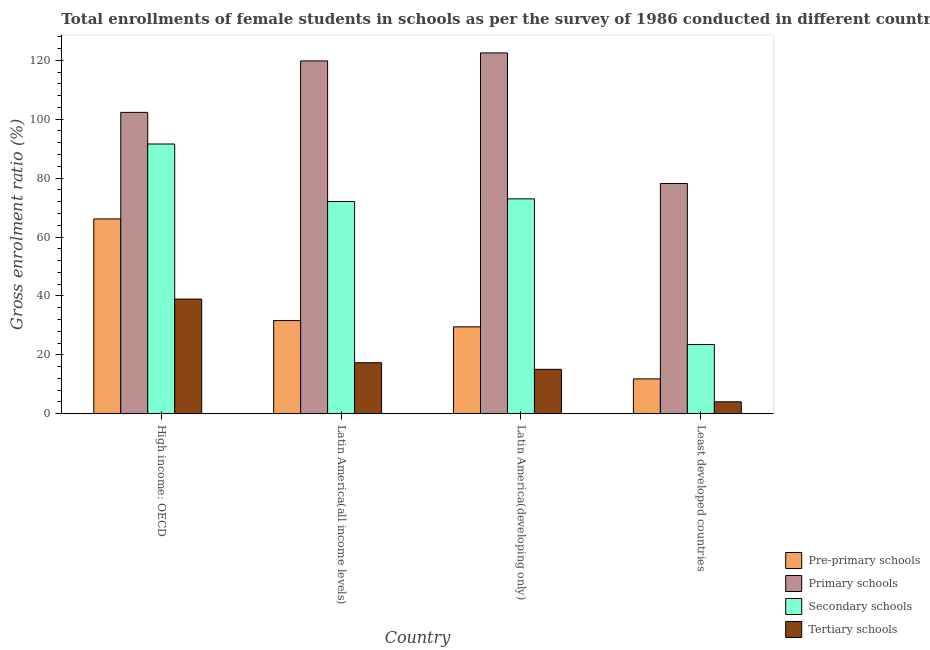How many groups of bars are there?
Give a very brief answer. 4. Are the number of bars per tick equal to the number of legend labels?
Make the answer very short. Yes. How many bars are there on the 1st tick from the right?
Give a very brief answer. 4. What is the label of the 1st group of bars from the left?
Your answer should be very brief. High income: OECD. What is the gross enrolment ratio(female) in primary schools in Latin America(all income levels)?
Your answer should be very brief. 119.79. Across all countries, what is the maximum gross enrolment ratio(female) in secondary schools?
Keep it short and to the point. 91.58. Across all countries, what is the minimum gross enrolment ratio(female) in tertiary schools?
Make the answer very short. 4.05. In which country was the gross enrolment ratio(female) in primary schools maximum?
Make the answer very short. Latin America(developing only). In which country was the gross enrolment ratio(female) in secondary schools minimum?
Provide a succinct answer. Least developed countries. What is the total gross enrolment ratio(female) in pre-primary schools in the graph?
Your answer should be compact. 139.11. What is the difference between the gross enrolment ratio(female) in primary schools in Latin America(developing only) and that in Least developed countries?
Make the answer very short. 44.34. What is the difference between the gross enrolment ratio(female) in pre-primary schools in Latin America(developing only) and the gross enrolment ratio(female) in secondary schools in Least developed countries?
Provide a short and direct response. 6. What is the average gross enrolment ratio(female) in tertiary schools per country?
Ensure brevity in your answer.  18.84. What is the difference between the gross enrolment ratio(female) in primary schools and gross enrolment ratio(female) in tertiary schools in Least developed countries?
Offer a terse response. 74.11. In how many countries, is the gross enrolment ratio(female) in primary schools greater than 76 %?
Make the answer very short. 4. What is the ratio of the gross enrolment ratio(female) in secondary schools in Latin America(all income levels) to that in Latin America(developing only)?
Your response must be concise. 0.99. What is the difference between the highest and the second highest gross enrolment ratio(female) in secondary schools?
Offer a very short reply. 18.62. What is the difference between the highest and the lowest gross enrolment ratio(female) in primary schools?
Keep it short and to the point. 44.34. Is the sum of the gross enrolment ratio(female) in pre-primary schools in Latin America(developing only) and Least developed countries greater than the maximum gross enrolment ratio(female) in secondary schools across all countries?
Ensure brevity in your answer.  No. What does the 1st bar from the left in High income: OECD represents?
Provide a succinct answer. Pre-primary schools. What does the 1st bar from the right in Least developed countries represents?
Offer a very short reply. Tertiary schools. Is it the case that in every country, the sum of the gross enrolment ratio(female) in pre-primary schools and gross enrolment ratio(female) in primary schools is greater than the gross enrolment ratio(female) in secondary schools?
Provide a short and direct response. Yes. Does the graph contain any zero values?
Make the answer very short. No. Where does the legend appear in the graph?
Provide a short and direct response. Bottom right. How are the legend labels stacked?
Your answer should be compact. Vertical. What is the title of the graph?
Provide a short and direct response. Total enrollments of female students in schools as per the survey of 1986 conducted in different countries. What is the Gross enrolment ratio (%) in Pre-primary schools in High income: OECD?
Keep it short and to the point. 66.15. What is the Gross enrolment ratio (%) of Primary schools in High income: OECD?
Offer a terse response. 102.32. What is the Gross enrolment ratio (%) in Secondary schools in High income: OECD?
Provide a succinct answer. 91.58. What is the Gross enrolment ratio (%) in Tertiary schools in High income: OECD?
Provide a short and direct response. 38.93. What is the Gross enrolment ratio (%) of Pre-primary schools in Latin America(all income levels)?
Ensure brevity in your answer.  31.63. What is the Gross enrolment ratio (%) of Primary schools in Latin America(all income levels)?
Ensure brevity in your answer.  119.79. What is the Gross enrolment ratio (%) of Secondary schools in Latin America(all income levels)?
Your answer should be compact. 72.05. What is the Gross enrolment ratio (%) in Tertiary schools in Latin America(all income levels)?
Make the answer very short. 17.33. What is the Gross enrolment ratio (%) in Pre-primary schools in Latin America(developing only)?
Make the answer very short. 29.5. What is the Gross enrolment ratio (%) in Primary schools in Latin America(developing only)?
Provide a short and direct response. 122.51. What is the Gross enrolment ratio (%) in Secondary schools in Latin America(developing only)?
Provide a succinct answer. 72.96. What is the Gross enrolment ratio (%) of Tertiary schools in Latin America(developing only)?
Your answer should be very brief. 15.08. What is the Gross enrolment ratio (%) of Pre-primary schools in Least developed countries?
Provide a succinct answer. 11.84. What is the Gross enrolment ratio (%) in Primary schools in Least developed countries?
Your response must be concise. 78.16. What is the Gross enrolment ratio (%) in Secondary schools in Least developed countries?
Offer a very short reply. 23.5. What is the Gross enrolment ratio (%) of Tertiary schools in Least developed countries?
Make the answer very short. 4.05. Across all countries, what is the maximum Gross enrolment ratio (%) of Pre-primary schools?
Keep it short and to the point. 66.15. Across all countries, what is the maximum Gross enrolment ratio (%) in Primary schools?
Keep it short and to the point. 122.51. Across all countries, what is the maximum Gross enrolment ratio (%) in Secondary schools?
Keep it short and to the point. 91.58. Across all countries, what is the maximum Gross enrolment ratio (%) in Tertiary schools?
Ensure brevity in your answer.  38.93. Across all countries, what is the minimum Gross enrolment ratio (%) in Pre-primary schools?
Give a very brief answer. 11.84. Across all countries, what is the minimum Gross enrolment ratio (%) in Primary schools?
Offer a very short reply. 78.16. Across all countries, what is the minimum Gross enrolment ratio (%) in Secondary schools?
Keep it short and to the point. 23.5. Across all countries, what is the minimum Gross enrolment ratio (%) of Tertiary schools?
Provide a succinct answer. 4.05. What is the total Gross enrolment ratio (%) in Pre-primary schools in the graph?
Give a very brief answer. 139.11. What is the total Gross enrolment ratio (%) in Primary schools in the graph?
Provide a short and direct response. 422.78. What is the total Gross enrolment ratio (%) in Secondary schools in the graph?
Offer a terse response. 260.09. What is the total Gross enrolment ratio (%) of Tertiary schools in the graph?
Keep it short and to the point. 75.38. What is the difference between the Gross enrolment ratio (%) in Pre-primary schools in High income: OECD and that in Latin America(all income levels)?
Your answer should be very brief. 34.52. What is the difference between the Gross enrolment ratio (%) of Primary schools in High income: OECD and that in Latin America(all income levels)?
Ensure brevity in your answer.  -17.47. What is the difference between the Gross enrolment ratio (%) of Secondary schools in High income: OECD and that in Latin America(all income levels)?
Your answer should be very brief. 19.53. What is the difference between the Gross enrolment ratio (%) in Tertiary schools in High income: OECD and that in Latin America(all income levels)?
Ensure brevity in your answer.  21.6. What is the difference between the Gross enrolment ratio (%) in Pre-primary schools in High income: OECD and that in Latin America(developing only)?
Give a very brief answer. 36.64. What is the difference between the Gross enrolment ratio (%) of Primary schools in High income: OECD and that in Latin America(developing only)?
Your response must be concise. -20.19. What is the difference between the Gross enrolment ratio (%) in Secondary schools in High income: OECD and that in Latin America(developing only)?
Provide a short and direct response. 18.62. What is the difference between the Gross enrolment ratio (%) in Tertiary schools in High income: OECD and that in Latin America(developing only)?
Provide a succinct answer. 23.85. What is the difference between the Gross enrolment ratio (%) in Pre-primary schools in High income: OECD and that in Least developed countries?
Keep it short and to the point. 54.31. What is the difference between the Gross enrolment ratio (%) in Primary schools in High income: OECD and that in Least developed countries?
Ensure brevity in your answer.  24.16. What is the difference between the Gross enrolment ratio (%) in Secondary schools in High income: OECD and that in Least developed countries?
Make the answer very short. 68.08. What is the difference between the Gross enrolment ratio (%) in Tertiary schools in High income: OECD and that in Least developed countries?
Your answer should be compact. 34.88. What is the difference between the Gross enrolment ratio (%) of Pre-primary schools in Latin America(all income levels) and that in Latin America(developing only)?
Your answer should be compact. 2.13. What is the difference between the Gross enrolment ratio (%) of Primary schools in Latin America(all income levels) and that in Latin America(developing only)?
Offer a terse response. -2.71. What is the difference between the Gross enrolment ratio (%) of Secondary schools in Latin America(all income levels) and that in Latin America(developing only)?
Provide a short and direct response. -0.9. What is the difference between the Gross enrolment ratio (%) of Tertiary schools in Latin America(all income levels) and that in Latin America(developing only)?
Provide a short and direct response. 2.25. What is the difference between the Gross enrolment ratio (%) in Pre-primary schools in Latin America(all income levels) and that in Least developed countries?
Offer a terse response. 19.79. What is the difference between the Gross enrolment ratio (%) of Primary schools in Latin America(all income levels) and that in Least developed countries?
Your response must be concise. 41.63. What is the difference between the Gross enrolment ratio (%) in Secondary schools in Latin America(all income levels) and that in Least developed countries?
Your answer should be very brief. 48.55. What is the difference between the Gross enrolment ratio (%) in Tertiary schools in Latin America(all income levels) and that in Least developed countries?
Keep it short and to the point. 13.28. What is the difference between the Gross enrolment ratio (%) in Pre-primary schools in Latin America(developing only) and that in Least developed countries?
Ensure brevity in your answer.  17.67. What is the difference between the Gross enrolment ratio (%) of Primary schools in Latin America(developing only) and that in Least developed countries?
Provide a short and direct response. 44.34. What is the difference between the Gross enrolment ratio (%) in Secondary schools in Latin America(developing only) and that in Least developed countries?
Give a very brief answer. 49.46. What is the difference between the Gross enrolment ratio (%) of Tertiary schools in Latin America(developing only) and that in Least developed countries?
Give a very brief answer. 11.03. What is the difference between the Gross enrolment ratio (%) of Pre-primary schools in High income: OECD and the Gross enrolment ratio (%) of Primary schools in Latin America(all income levels)?
Ensure brevity in your answer.  -53.65. What is the difference between the Gross enrolment ratio (%) of Pre-primary schools in High income: OECD and the Gross enrolment ratio (%) of Secondary schools in Latin America(all income levels)?
Your answer should be very brief. -5.91. What is the difference between the Gross enrolment ratio (%) in Pre-primary schools in High income: OECD and the Gross enrolment ratio (%) in Tertiary schools in Latin America(all income levels)?
Provide a succinct answer. 48.82. What is the difference between the Gross enrolment ratio (%) in Primary schools in High income: OECD and the Gross enrolment ratio (%) in Secondary schools in Latin America(all income levels)?
Offer a terse response. 30.27. What is the difference between the Gross enrolment ratio (%) in Primary schools in High income: OECD and the Gross enrolment ratio (%) in Tertiary schools in Latin America(all income levels)?
Offer a very short reply. 84.99. What is the difference between the Gross enrolment ratio (%) of Secondary schools in High income: OECD and the Gross enrolment ratio (%) of Tertiary schools in Latin America(all income levels)?
Offer a terse response. 74.25. What is the difference between the Gross enrolment ratio (%) of Pre-primary schools in High income: OECD and the Gross enrolment ratio (%) of Primary schools in Latin America(developing only)?
Keep it short and to the point. -56.36. What is the difference between the Gross enrolment ratio (%) of Pre-primary schools in High income: OECD and the Gross enrolment ratio (%) of Secondary schools in Latin America(developing only)?
Offer a terse response. -6.81. What is the difference between the Gross enrolment ratio (%) of Pre-primary schools in High income: OECD and the Gross enrolment ratio (%) of Tertiary schools in Latin America(developing only)?
Keep it short and to the point. 51.07. What is the difference between the Gross enrolment ratio (%) of Primary schools in High income: OECD and the Gross enrolment ratio (%) of Secondary schools in Latin America(developing only)?
Your answer should be compact. 29.36. What is the difference between the Gross enrolment ratio (%) of Primary schools in High income: OECD and the Gross enrolment ratio (%) of Tertiary schools in Latin America(developing only)?
Make the answer very short. 87.24. What is the difference between the Gross enrolment ratio (%) in Secondary schools in High income: OECD and the Gross enrolment ratio (%) in Tertiary schools in Latin America(developing only)?
Keep it short and to the point. 76.5. What is the difference between the Gross enrolment ratio (%) of Pre-primary schools in High income: OECD and the Gross enrolment ratio (%) of Primary schools in Least developed countries?
Your answer should be very brief. -12.02. What is the difference between the Gross enrolment ratio (%) in Pre-primary schools in High income: OECD and the Gross enrolment ratio (%) in Secondary schools in Least developed countries?
Ensure brevity in your answer.  42.65. What is the difference between the Gross enrolment ratio (%) of Pre-primary schools in High income: OECD and the Gross enrolment ratio (%) of Tertiary schools in Least developed countries?
Your answer should be compact. 62.1. What is the difference between the Gross enrolment ratio (%) of Primary schools in High income: OECD and the Gross enrolment ratio (%) of Secondary schools in Least developed countries?
Your answer should be compact. 78.82. What is the difference between the Gross enrolment ratio (%) of Primary schools in High income: OECD and the Gross enrolment ratio (%) of Tertiary schools in Least developed countries?
Offer a terse response. 98.27. What is the difference between the Gross enrolment ratio (%) in Secondary schools in High income: OECD and the Gross enrolment ratio (%) in Tertiary schools in Least developed countries?
Your response must be concise. 87.53. What is the difference between the Gross enrolment ratio (%) in Pre-primary schools in Latin America(all income levels) and the Gross enrolment ratio (%) in Primary schools in Latin America(developing only)?
Offer a terse response. -90.88. What is the difference between the Gross enrolment ratio (%) in Pre-primary schools in Latin America(all income levels) and the Gross enrolment ratio (%) in Secondary schools in Latin America(developing only)?
Give a very brief answer. -41.33. What is the difference between the Gross enrolment ratio (%) in Pre-primary schools in Latin America(all income levels) and the Gross enrolment ratio (%) in Tertiary schools in Latin America(developing only)?
Ensure brevity in your answer.  16.55. What is the difference between the Gross enrolment ratio (%) in Primary schools in Latin America(all income levels) and the Gross enrolment ratio (%) in Secondary schools in Latin America(developing only)?
Offer a terse response. 46.84. What is the difference between the Gross enrolment ratio (%) of Primary schools in Latin America(all income levels) and the Gross enrolment ratio (%) of Tertiary schools in Latin America(developing only)?
Your response must be concise. 104.72. What is the difference between the Gross enrolment ratio (%) in Secondary schools in Latin America(all income levels) and the Gross enrolment ratio (%) in Tertiary schools in Latin America(developing only)?
Keep it short and to the point. 56.98. What is the difference between the Gross enrolment ratio (%) of Pre-primary schools in Latin America(all income levels) and the Gross enrolment ratio (%) of Primary schools in Least developed countries?
Give a very brief answer. -46.53. What is the difference between the Gross enrolment ratio (%) of Pre-primary schools in Latin America(all income levels) and the Gross enrolment ratio (%) of Secondary schools in Least developed countries?
Give a very brief answer. 8.13. What is the difference between the Gross enrolment ratio (%) of Pre-primary schools in Latin America(all income levels) and the Gross enrolment ratio (%) of Tertiary schools in Least developed countries?
Provide a short and direct response. 27.58. What is the difference between the Gross enrolment ratio (%) in Primary schools in Latin America(all income levels) and the Gross enrolment ratio (%) in Secondary schools in Least developed countries?
Provide a succinct answer. 96.29. What is the difference between the Gross enrolment ratio (%) of Primary schools in Latin America(all income levels) and the Gross enrolment ratio (%) of Tertiary schools in Least developed countries?
Ensure brevity in your answer.  115.74. What is the difference between the Gross enrolment ratio (%) of Secondary schools in Latin America(all income levels) and the Gross enrolment ratio (%) of Tertiary schools in Least developed countries?
Give a very brief answer. 68. What is the difference between the Gross enrolment ratio (%) in Pre-primary schools in Latin America(developing only) and the Gross enrolment ratio (%) in Primary schools in Least developed countries?
Offer a very short reply. -48.66. What is the difference between the Gross enrolment ratio (%) in Pre-primary schools in Latin America(developing only) and the Gross enrolment ratio (%) in Secondary schools in Least developed countries?
Offer a terse response. 6. What is the difference between the Gross enrolment ratio (%) in Pre-primary schools in Latin America(developing only) and the Gross enrolment ratio (%) in Tertiary schools in Least developed countries?
Keep it short and to the point. 25.45. What is the difference between the Gross enrolment ratio (%) of Primary schools in Latin America(developing only) and the Gross enrolment ratio (%) of Secondary schools in Least developed countries?
Provide a short and direct response. 99.01. What is the difference between the Gross enrolment ratio (%) in Primary schools in Latin America(developing only) and the Gross enrolment ratio (%) in Tertiary schools in Least developed countries?
Keep it short and to the point. 118.46. What is the difference between the Gross enrolment ratio (%) of Secondary schools in Latin America(developing only) and the Gross enrolment ratio (%) of Tertiary schools in Least developed countries?
Provide a short and direct response. 68.91. What is the average Gross enrolment ratio (%) in Pre-primary schools per country?
Provide a short and direct response. 34.78. What is the average Gross enrolment ratio (%) in Primary schools per country?
Your answer should be compact. 105.7. What is the average Gross enrolment ratio (%) of Secondary schools per country?
Make the answer very short. 65.02. What is the average Gross enrolment ratio (%) of Tertiary schools per country?
Make the answer very short. 18.84. What is the difference between the Gross enrolment ratio (%) in Pre-primary schools and Gross enrolment ratio (%) in Primary schools in High income: OECD?
Make the answer very short. -36.17. What is the difference between the Gross enrolment ratio (%) of Pre-primary schools and Gross enrolment ratio (%) of Secondary schools in High income: OECD?
Give a very brief answer. -25.43. What is the difference between the Gross enrolment ratio (%) of Pre-primary schools and Gross enrolment ratio (%) of Tertiary schools in High income: OECD?
Your answer should be very brief. 27.22. What is the difference between the Gross enrolment ratio (%) in Primary schools and Gross enrolment ratio (%) in Secondary schools in High income: OECD?
Provide a succinct answer. 10.74. What is the difference between the Gross enrolment ratio (%) in Primary schools and Gross enrolment ratio (%) in Tertiary schools in High income: OECD?
Keep it short and to the point. 63.4. What is the difference between the Gross enrolment ratio (%) of Secondary schools and Gross enrolment ratio (%) of Tertiary schools in High income: OECD?
Provide a succinct answer. 52.65. What is the difference between the Gross enrolment ratio (%) of Pre-primary schools and Gross enrolment ratio (%) of Primary schools in Latin America(all income levels)?
Offer a terse response. -88.16. What is the difference between the Gross enrolment ratio (%) in Pre-primary schools and Gross enrolment ratio (%) in Secondary schools in Latin America(all income levels)?
Offer a very short reply. -40.43. What is the difference between the Gross enrolment ratio (%) of Pre-primary schools and Gross enrolment ratio (%) of Tertiary schools in Latin America(all income levels)?
Offer a very short reply. 14.3. What is the difference between the Gross enrolment ratio (%) of Primary schools and Gross enrolment ratio (%) of Secondary schools in Latin America(all income levels)?
Offer a very short reply. 47.74. What is the difference between the Gross enrolment ratio (%) of Primary schools and Gross enrolment ratio (%) of Tertiary schools in Latin America(all income levels)?
Keep it short and to the point. 102.47. What is the difference between the Gross enrolment ratio (%) in Secondary schools and Gross enrolment ratio (%) in Tertiary schools in Latin America(all income levels)?
Your response must be concise. 54.73. What is the difference between the Gross enrolment ratio (%) of Pre-primary schools and Gross enrolment ratio (%) of Primary schools in Latin America(developing only)?
Ensure brevity in your answer.  -93. What is the difference between the Gross enrolment ratio (%) in Pre-primary schools and Gross enrolment ratio (%) in Secondary schools in Latin America(developing only)?
Your answer should be compact. -43.45. What is the difference between the Gross enrolment ratio (%) of Pre-primary schools and Gross enrolment ratio (%) of Tertiary schools in Latin America(developing only)?
Provide a short and direct response. 14.43. What is the difference between the Gross enrolment ratio (%) of Primary schools and Gross enrolment ratio (%) of Secondary schools in Latin America(developing only)?
Offer a terse response. 49.55. What is the difference between the Gross enrolment ratio (%) in Primary schools and Gross enrolment ratio (%) in Tertiary schools in Latin America(developing only)?
Provide a short and direct response. 107.43. What is the difference between the Gross enrolment ratio (%) of Secondary schools and Gross enrolment ratio (%) of Tertiary schools in Latin America(developing only)?
Make the answer very short. 57.88. What is the difference between the Gross enrolment ratio (%) of Pre-primary schools and Gross enrolment ratio (%) of Primary schools in Least developed countries?
Your answer should be very brief. -66.33. What is the difference between the Gross enrolment ratio (%) of Pre-primary schools and Gross enrolment ratio (%) of Secondary schools in Least developed countries?
Offer a very short reply. -11.66. What is the difference between the Gross enrolment ratio (%) in Pre-primary schools and Gross enrolment ratio (%) in Tertiary schools in Least developed countries?
Ensure brevity in your answer.  7.79. What is the difference between the Gross enrolment ratio (%) in Primary schools and Gross enrolment ratio (%) in Secondary schools in Least developed countries?
Provide a short and direct response. 54.66. What is the difference between the Gross enrolment ratio (%) in Primary schools and Gross enrolment ratio (%) in Tertiary schools in Least developed countries?
Offer a terse response. 74.11. What is the difference between the Gross enrolment ratio (%) of Secondary schools and Gross enrolment ratio (%) of Tertiary schools in Least developed countries?
Your answer should be compact. 19.45. What is the ratio of the Gross enrolment ratio (%) of Pre-primary schools in High income: OECD to that in Latin America(all income levels)?
Keep it short and to the point. 2.09. What is the ratio of the Gross enrolment ratio (%) in Primary schools in High income: OECD to that in Latin America(all income levels)?
Make the answer very short. 0.85. What is the ratio of the Gross enrolment ratio (%) of Secondary schools in High income: OECD to that in Latin America(all income levels)?
Make the answer very short. 1.27. What is the ratio of the Gross enrolment ratio (%) in Tertiary schools in High income: OECD to that in Latin America(all income levels)?
Offer a very short reply. 2.25. What is the ratio of the Gross enrolment ratio (%) of Pre-primary schools in High income: OECD to that in Latin America(developing only)?
Give a very brief answer. 2.24. What is the ratio of the Gross enrolment ratio (%) of Primary schools in High income: OECD to that in Latin America(developing only)?
Provide a short and direct response. 0.84. What is the ratio of the Gross enrolment ratio (%) of Secondary schools in High income: OECD to that in Latin America(developing only)?
Your response must be concise. 1.26. What is the ratio of the Gross enrolment ratio (%) in Tertiary schools in High income: OECD to that in Latin America(developing only)?
Provide a succinct answer. 2.58. What is the ratio of the Gross enrolment ratio (%) in Pre-primary schools in High income: OECD to that in Least developed countries?
Ensure brevity in your answer.  5.59. What is the ratio of the Gross enrolment ratio (%) in Primary schools in High income: OECD to that in Least developed countries?
Ensure brevity in your answer.  1.31. What is the ratio of the Gross enrolment ratio (%) in Secondary schools in High income: OECD to that in Least developed countries?
Offer a very short reply. 3.9. What is the ratio of the Gross enrolment ratio (%) of Tertiary schools in High income: OECD to that in Least developed countries?
Offer a very short reply. 9.61. What is the ratio of the Gross enrolment ratio (%) in Pre-primary schools in Latin America(all income levels) to that in Latin America(developing only)?
Your answer should be compact. 1.07. What is the ratio of the Gross enrolment ratio (%) of Primary schools in Latin America(all income levels) to that in Latin America(developing only)?
Offer a very short reply. 0.98. What is the ratio of the Gross enrolment ratio (%) in Secondary schools in Latin America(all income levels) to that in Latin America(developing only)?
Your response must be concise. 0.99. What is the ratio of the Gross enrolment ratio (%) in Tertiary schools in Latin America(all income levels) to that in Latin America(developing only)?
Make the answer very short. 1.15. What is the ratio of the Gross enrolment ratio (%) in Pre-primary schools in Latin America(all income levels) to that in Least developed countries?
Offer a very short reply. 2.67. What is the ratio of the Gross enrolment ratio (%) in Primary schools in Latin America(all income levels) to that in Least developed countries?
Give a very brief answer. 1.53. What is the ratio of the Gross enrolment ratio (%) in Secondary schools in Latin America(all income levels) to that in Least developed countries?
Offer a very short reply. 3.07. What is the ratio of the Gross enrolment ratio (%) of Tertiary schools in Latin America(all income levels) to that in Least developed countries?
Your response must be concise. 4.28. What is the ratio of the Gross enrolment ratio (%) of Pre-primary schools in Latin America(developing only) to that in Least developed countries?
Give a very brief answer. 2.49. What is the ratio of the Gross enrolment ratio (%) of Primary schools in Latin America(developing only) to that in Least developed countries?
Your answer should be very brief. 1.57. What is the ratio of the Gross enrolment ratio (%) in Secondary schools in Latin America(developing only) to that in Least developed countries?
Give a very brief answer. 3.1. What is the ratio of the Gross enrolment ratio (%) of Tertiary schools in Latin America(developing only) to that in Least developed countries?
Keep it short and to the point. 3.72. What is the difference between the highest and the second highest Gross enrolment ratio (%) in Pre-primary schools?
Give a very brief answer. 34.52. What is the difference between the highest and the second highest Gross enrolment ratio (%) of Primary schools?
Your answer should be very brief. 2.71. What is the difference between the highest and the second highest Gross enrolment ratio (%) in Secondary schools?
Provide a short and direct response. 18.62. What is the difference between the highest and the second highest Gross enrolment ratio (%) of Tertiary schools?
Your answer should be compact. 21.6. What is the difference between the highest and the lowest Gross enrolment ratio (%) in Pre-primary schools?
Provide a succinct answer. 54.31. What is the difference between the highest and the lowest Gross enrolment ratio (%) of Primary schools?
Provide a succinct answer. 44.34. What is the difference between the highest and the lowest Gross enrolment ratio (%) of Secondary schools?
Keep it short and to the point. 68.08. What is the difference between the highest and the lowest Gross enrolment ratio (%) of Tertiary schools?
Make the answer very short. 34.88. 